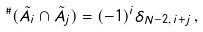<formula> <loc_0><loc_0><loc_500><loc_500>{ } ^ { \# } ( \tilde { A } _ { i } \cap \tilde { A } _ { j } ) = ( - 1 ) ^ { i } \delta _ { N - 2 , \, i + j } \, ,</formula> 